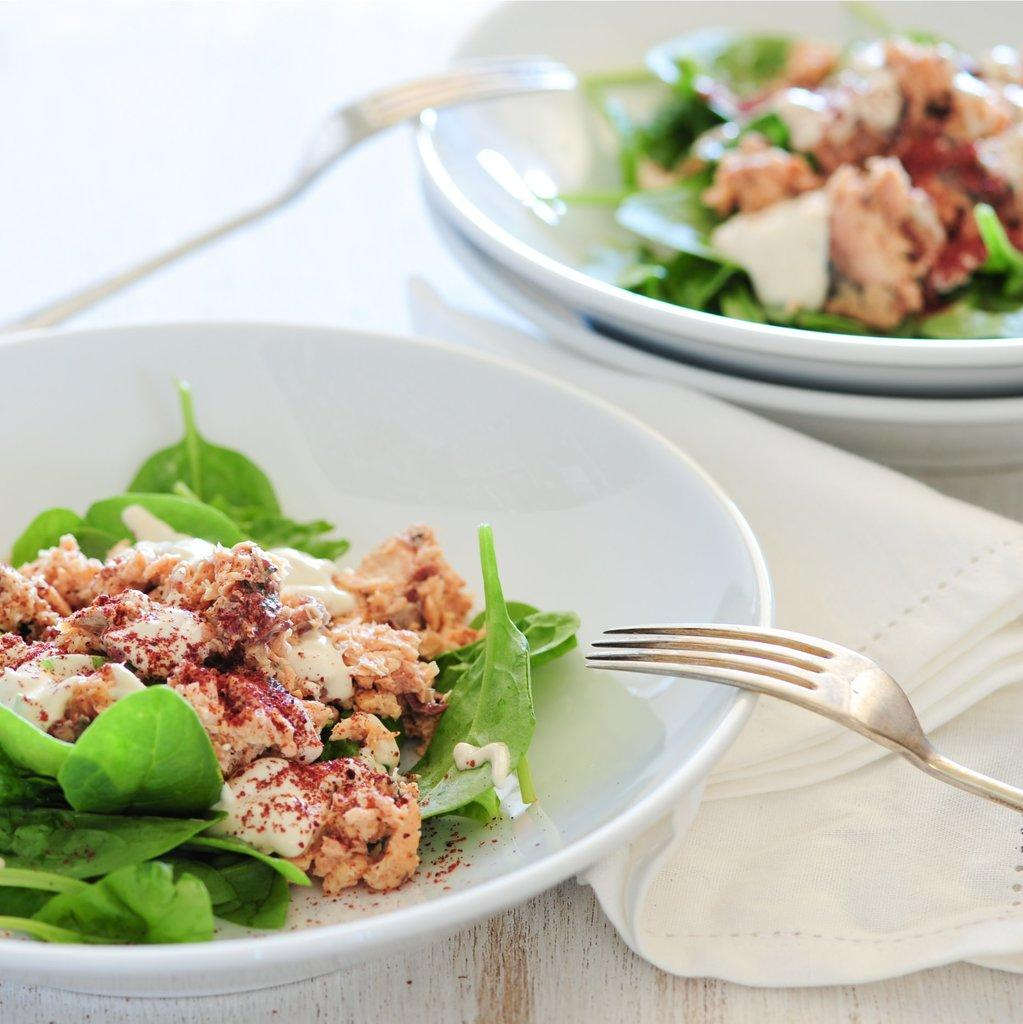What type of objects can be seen in the image? There are plates, food items, forks, and tissue papers in the image. How are these objects arranged? All these items are placed on a platform. What might be used for eating the food items in the image? The forks in the image can be used for eating the food items. What can be used for cleaning or wiping in the image? Tissue papers are present in the image for cleaning or wiping. What color are the eyes of the pet in the image? There is no pet present in the image. 